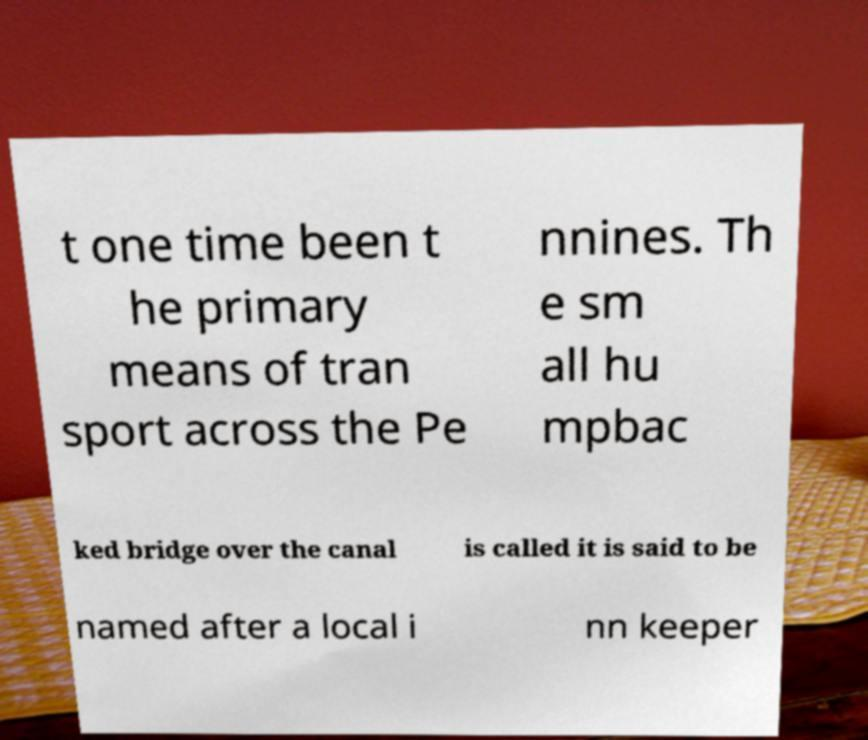There's text embedded in this image that I need extracted. Can you transcribe it verbatim? t one time been t he primary means of tran sport across the Pe nnines. Th e sm all hu mpbac ked bridge over the canal is called it is said to be named after a local i nn keeper 